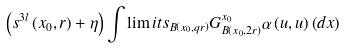Convert formula to latex. <formula><loc_0><loc_0><loc_500><loc_500>\left ( s ^ { 3 l } \left ( x _ { 0 } , r \right ) + \eta \right ) \int \lim i t s _ { B \left ( x _ { 0 } , q r \right ) } G _ { B \left ( x _ { 0 } , 2 r \right ) } ^ { x _ { 0 } } \alpha \left ( u , u \right ) \left ( d x \right )</formula> 